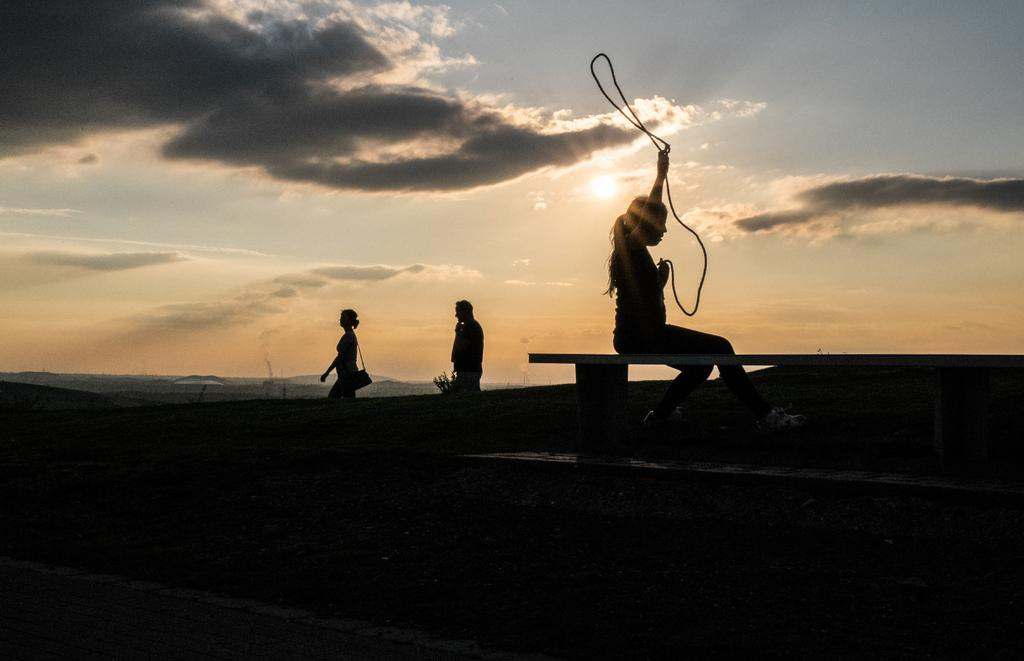What type of image is being displayed? The image is a silhouette. Can you describe the main subject in the silhouette? There is a woman in the image. What is the woman doing in the image? The woman is sitting on a bench and doing some exercise. Are there any other people visible in the image? Yes, there are two other people behind the woman. What type of glass can be seen in the woman's hand in the image? There is no glass present in the woman's hand or in the image. What type of sport are the people playing in the image? There is no sport being played in the image; the woman is doing exercise while sitting on a bench. 